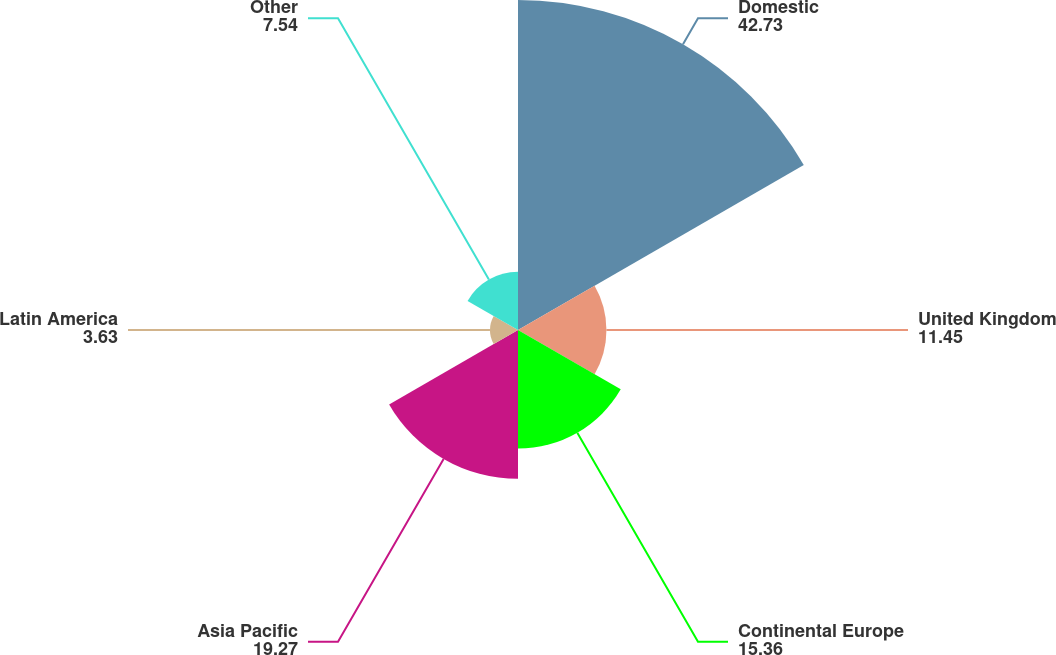Convert chart to OTSL. <chart><loc_0><loc_0><loc_500><loc_500><pie_chart><fcel>Domestic<fcel>United Kingdom<fcel>Continental Europe<fcel>Asia Pacific<fcel>Latin America<fcel>Other<nl><fcel>42.73%<fcel>11.45%<fcel>15.36%<fcel>19.27%<fcel>3.63%<fcel>7.54%<nl></chart> 